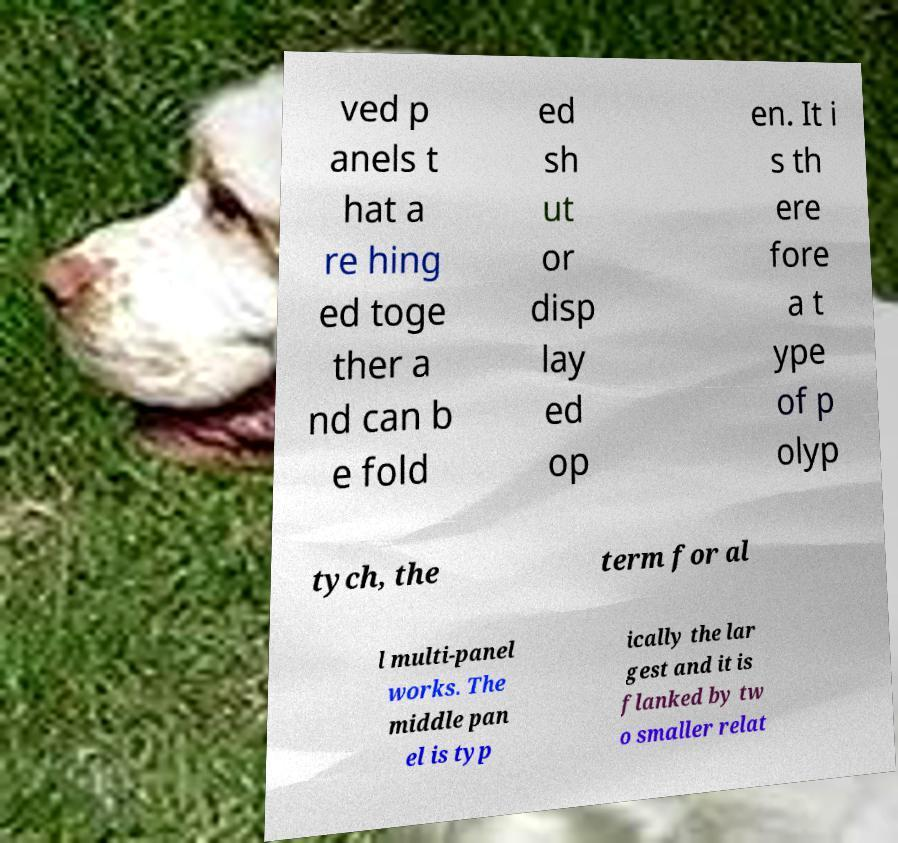Could you assist in decoding the text presented in this image and type it out clearly? ved p anels t hat a re hing ed toge ther a nd can b e fold ed sh ut or disp lay ed op en. It i s th ere fore a t ype of p olyp tych, the term for al l multi-panel works. The middle pan el is typ ically the lar gest and it is flanked by tw o smaller relat 